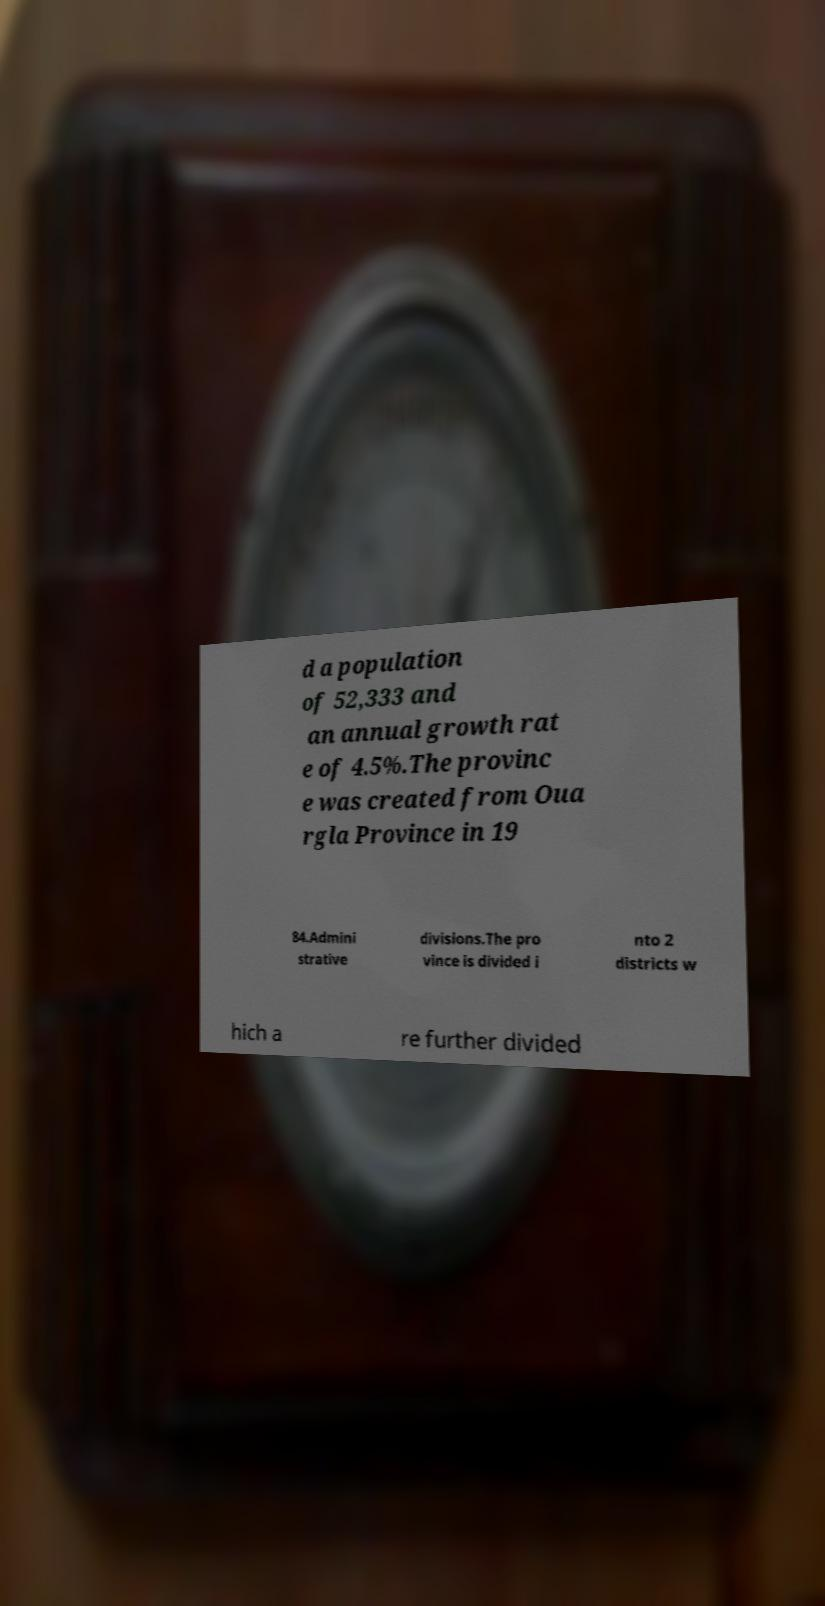Could you assist in decoding the text presented in this image and type it out clearly? d a population of 52,333 and an annual growth rat e of 4.5%.The provinc e was created from Oua rgla Province in 19 84.Admini strative divisions.The pro vince is divided i nto 2 districts w hich a re further divided 